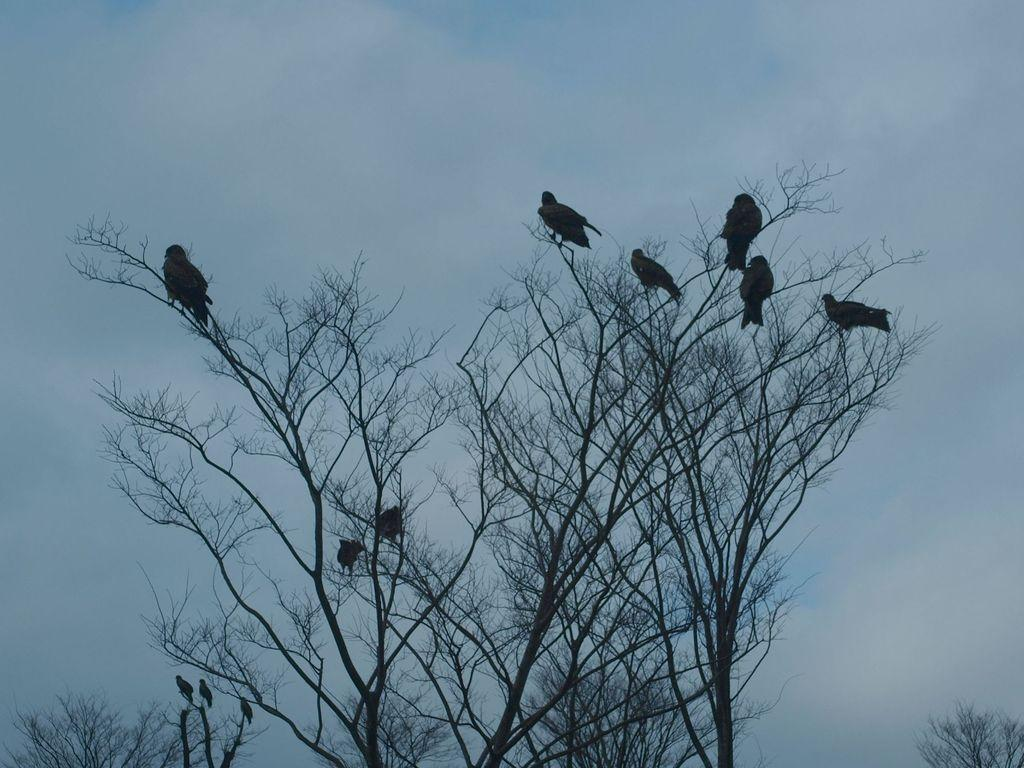What type of animals can be seen in the image? There are many birds in the image. Where are the birds located in the image? The birds are sitting on the branches of trees. How would you describe the sky in the image? The sky appears gloomy in the image. What type of agreement is being discussed by the birds in the image? There is no indication in the image that the birds are discussing any agreements. What action are the birds taking in the image? The birds are sitting on the branches of trees, which is a resting or perching action. 